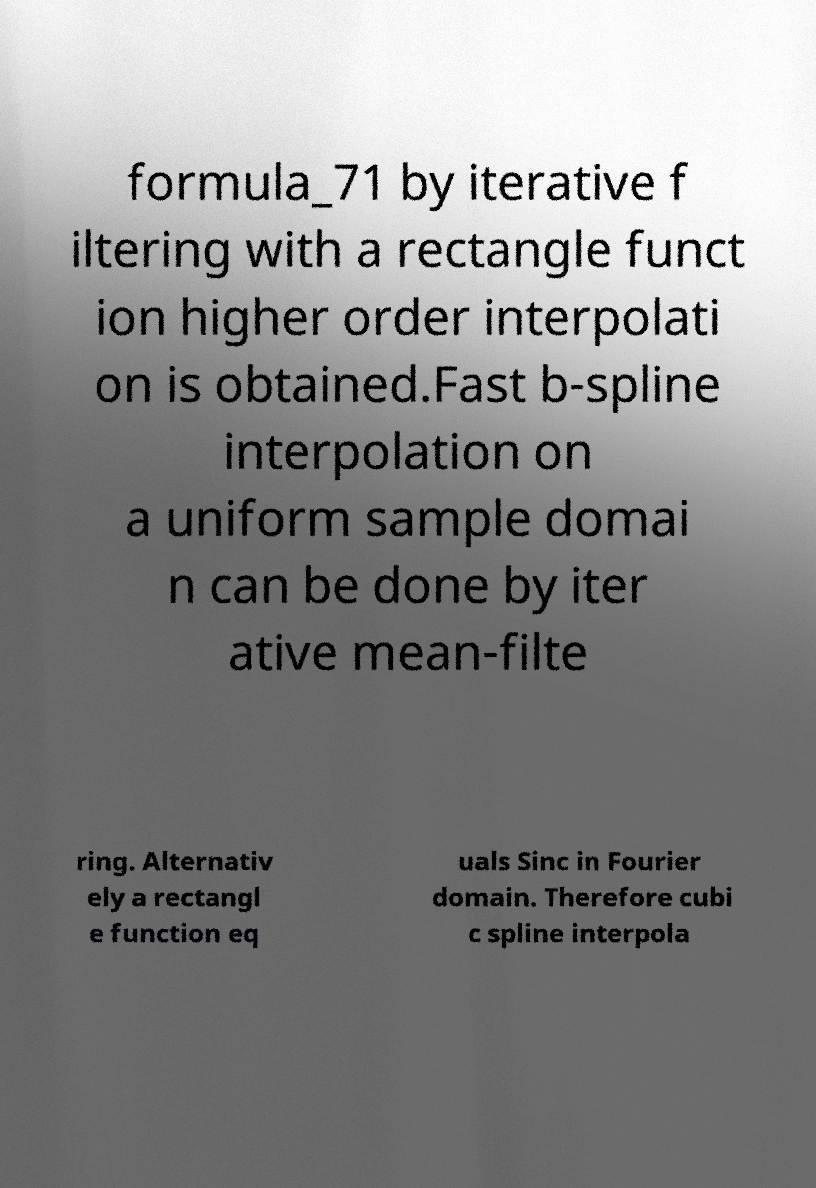Can you accurately transcribe the text from the provided image for me? formula_71 by iterative f iltering with a rectangle funct ion higher order interpolati on is obtained.Fast b-spline interpolation on a uniform sample domai n can be done by iter ative mean-filte ring. Alternativ ely a rectangl e function eq uals Sinc in Fourier domain. Therefore cubi c spline interpola 